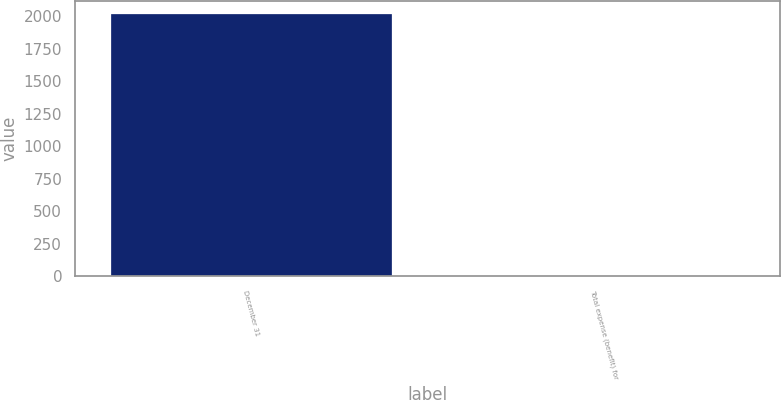Convert chart. <chart><loc_0><loc_0><loc_500><loc_500><bar_chart><fcel>December 31<fcel>Total expense (benefit) for<nl><fcel>2018<fcel>3<nl></chart> 